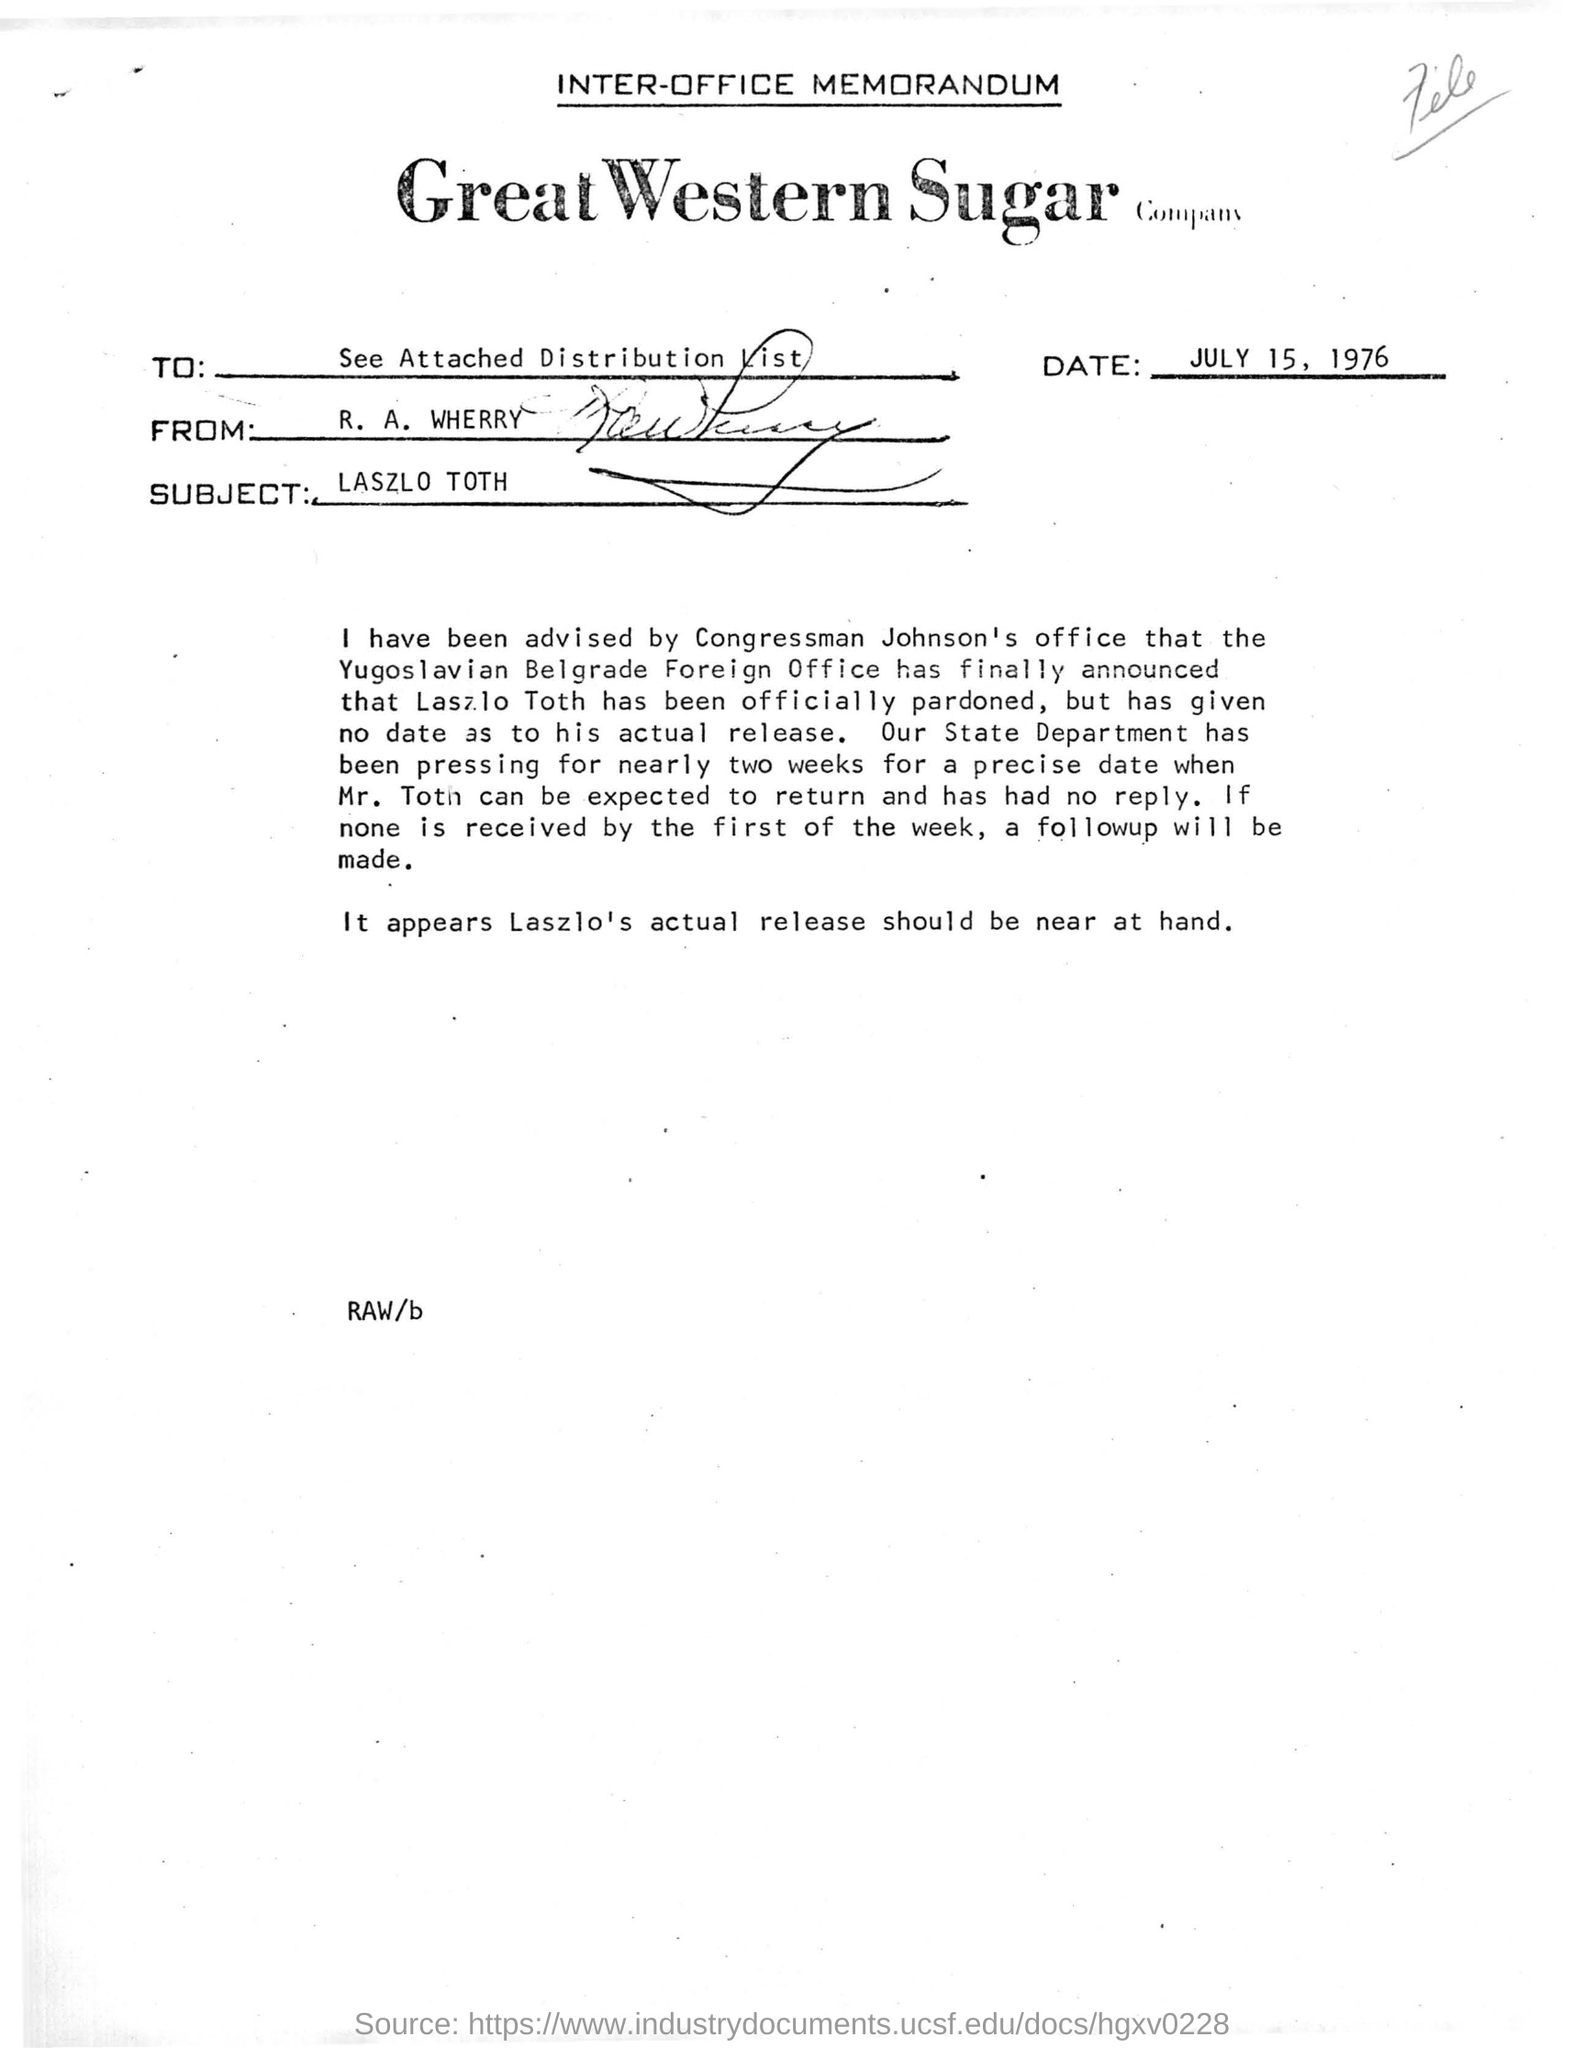What kind of memorandum in the document?
Your answer should be compact. INTER-OFFICE MEMORANDUM. What is the name of sugar company?
Offer a very short reply. GREAT WESTERN SUGAR COMPANY. What is the subject of the inter-office memorandum?
Make the answer very short. LASZLO TOTH. When inter-office memorandum is dated?
Offer a terse response. JULY 15, 1976. Who is writing this memorandum?
Make the answer very short. R. A. WHERRY. Which country's foreign office has finally announced that laszlo toth has been officially pardoned?
Provide a short and direct response. Yugoslavian Belgrade. 